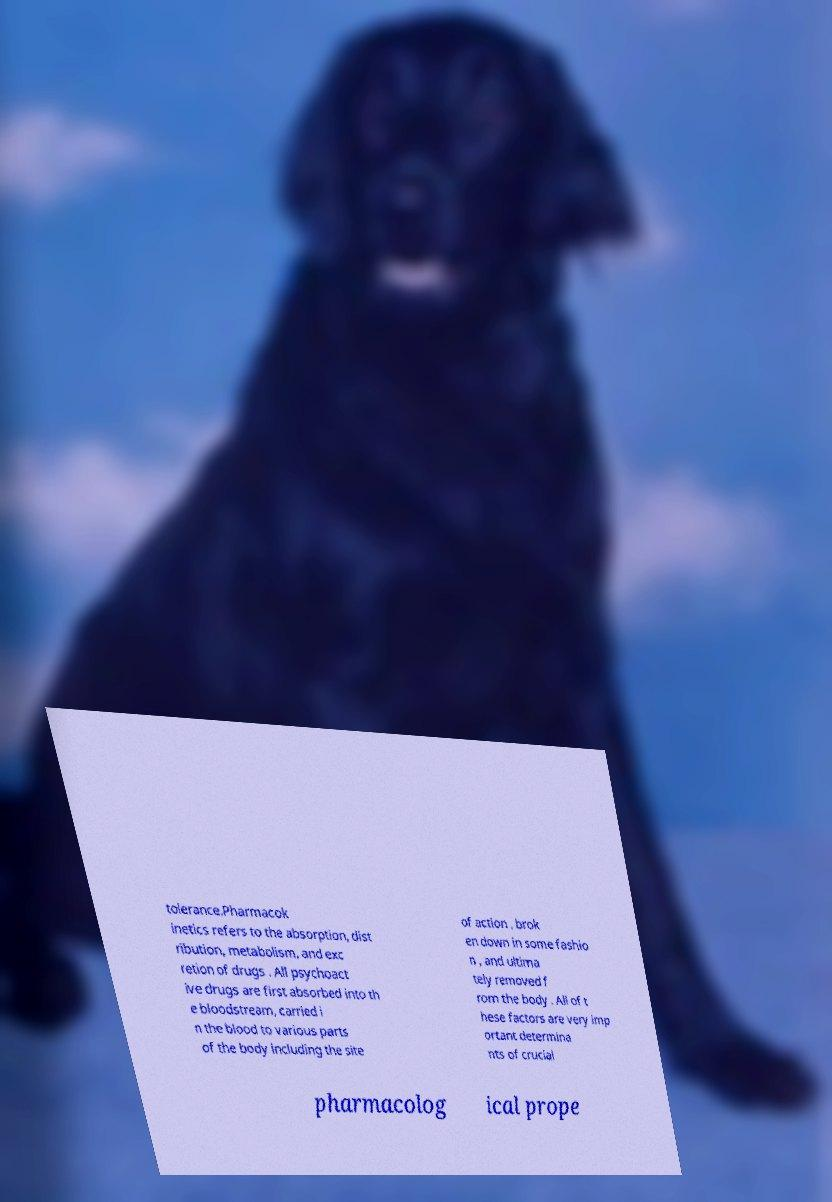What messages or text are displayed in this image? I need them in a readable, typed format. tolerance.Pharmacok inetics refers to the absorption, dist ribution, metabolism, and exc retion of drugs . All psychoact ive drugs are first absorbed into th e bloodstream, carried i n the blood to various parts of the body including the site of action , brok en down in some fashio n , and ultima tely removed f rom the body . All of t hese factors are very imp ortant determina nts of crucial pharmacolog ical prope 